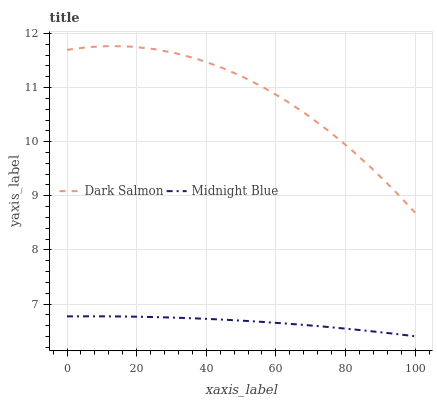Does Midnight Blue have the minimum area under the curve?
Answer yes or no. Yes. Does Dark Salmon have the maximum area under the curve?
Answer yes or no. Yes. Does Midnight Blue have the maximum area under the curve?
Answer yes or no. No. Is Midnight Blue the smoothest?
Answer yes or no. Yes. Is Dark Salmon the roughest?
Answer yes or no. Yes. Is Midnight Blue the roughest?
Answer yes or no. No. Does Midnight Blue have the highest value?
Answer yes or no. No. Is Midnight Blue less than Dark Salmon?
Answer yes or no. Yes. Is Dark Salmon greater than Midnight Blue?
Answer yes or no. Yes. Does Midnight Blue intersect Dark Salmon?
Answer yes or no. No. 